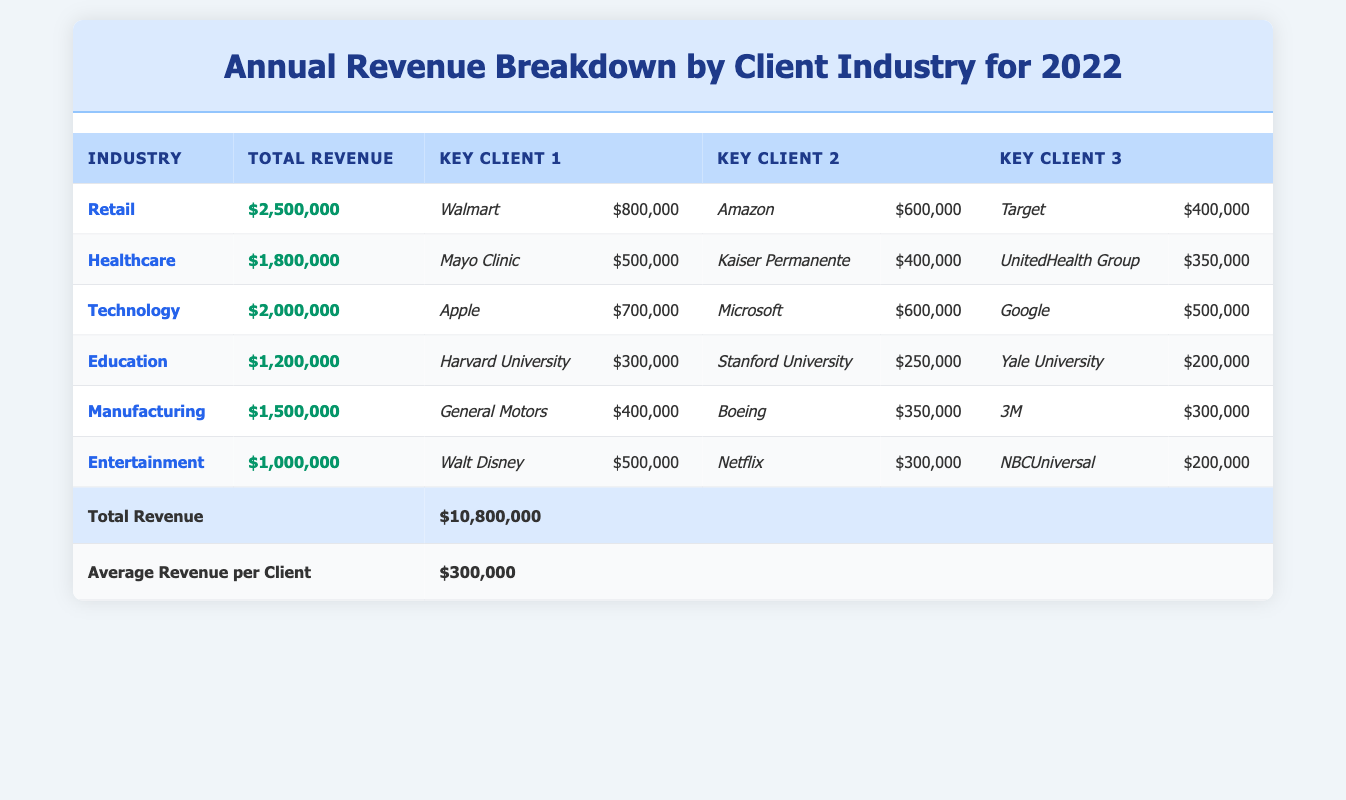What is the total revenue from the Retail industry? The table shows that the total revenue from the Retail industry is listed as $2,500,000.
Answer: $2,500,000 Which key client contributed the most revenue in the Healthcare sector? In the Healthcare sector, Mayo Clinic has the highest revenue contribution of $500,000.
Answer: Mayo Clinic How much total revenue was generated from the Technology sector? The Technology sector shows a total revenue of $2,000,000 in the table.
Answer: $2,000,000 What is the average revenue per client across all industries? The summary row indicates that the average revenue per client is calculated as $300,000.
Answer: $300,000 Is the total revenue from the Entertainment industry greater than that from the Education industry? The total revenue from the Entertainment industry is $1,000,000, while that from the Education industry is $1,200,000. Therefore, it is false that Entertainment exceeds Education.
Answer: No What is the total revenue from all industries combined? The 'Total Revenue' summary shows a total of $10,800,000 from all industries.
Answer: $10,800,000 How much does Amazon contribute to the overall revenue? Amazon contributes $600,000 in revenue as indicated under the Retail industry key clients section.
Answer: $600,000 If you sum up the total revenue from Healthcare and Manufacturing, what would it be? Adding the total revenues: Healthcare ($1,800,000) + Manufacturing ($1,500,000) gives $3,300,000.
Answer: $3,300,000 Which industry shows the lowest total revenue, and how much is it? The Entertainment industry shows the lowest total revenue of $1,000,000 compared to all other industries presented.
Answer: Entertainment, $1,000,000 How much revenue does General Motors generate in comparison to Google's revenue? General Motors contributes $400,000 in revenue, while Google contributes $500,000; therefore, Google generates more.
Answer: Google's revenue is higher 